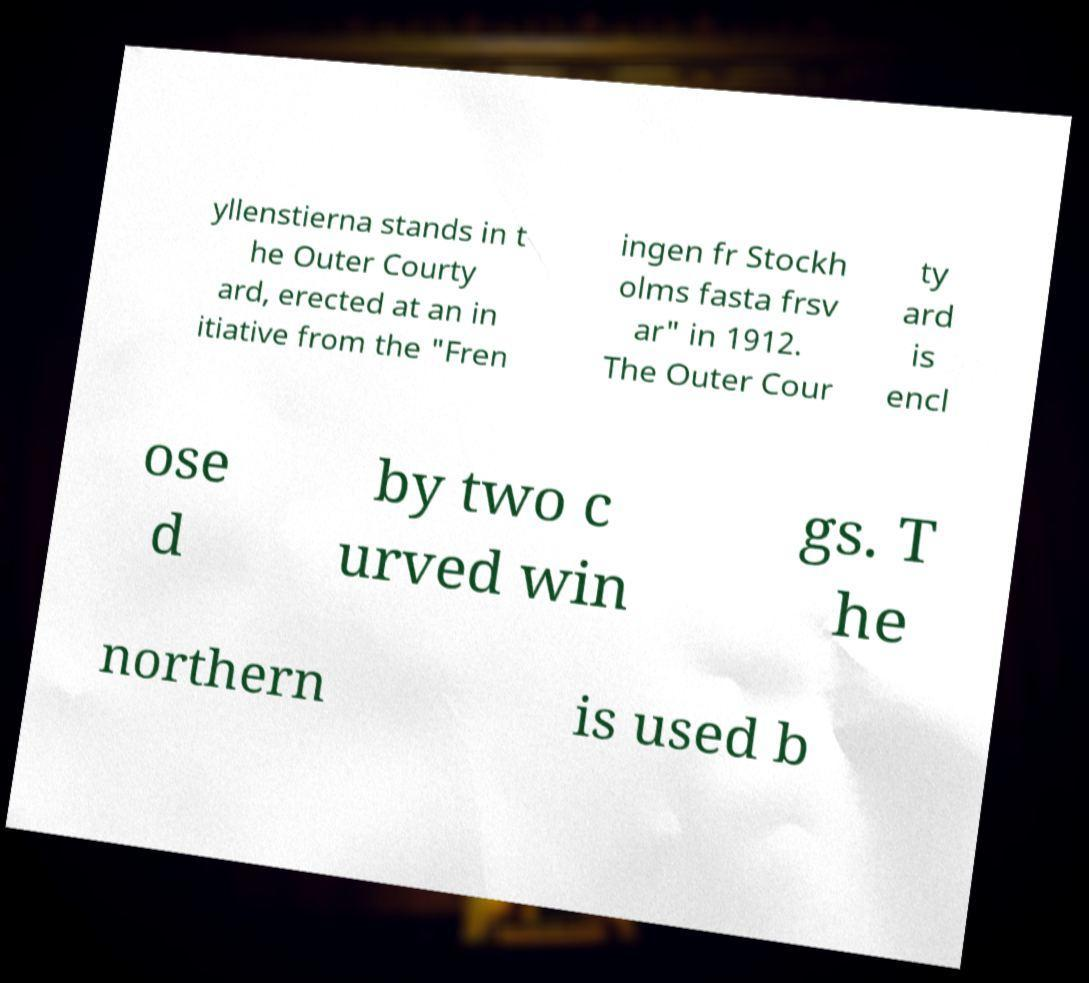Could you assist in decoding the text presented in this image and type it out clearly? yllenstierna stands in t he Outer Courty ard, erected at an in itiative from the "Fren ingen fr Stockh olms fasta frsv ar" in 1912. The Outer Cour ty ard is encl ose d by two c urved win gs. T he northern is used b 